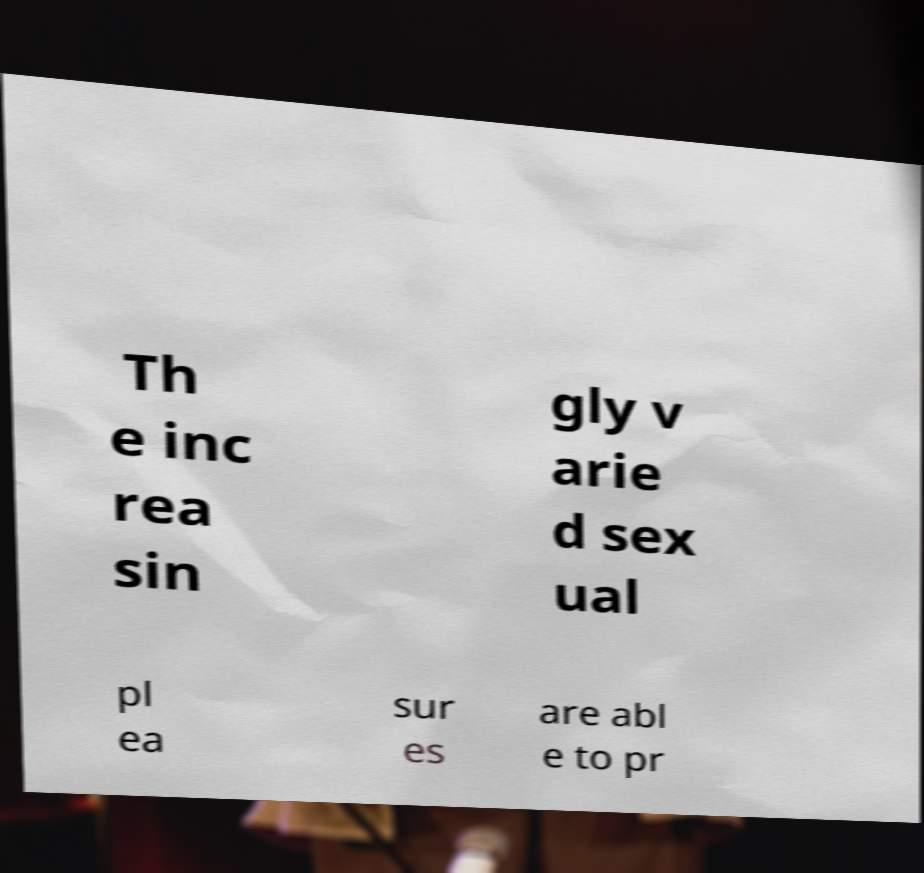I need the written content from this picture converted into text. Can you do that? Th e inc rea sin gly v arie d sex ual pl ea sur es are abl e to pr 